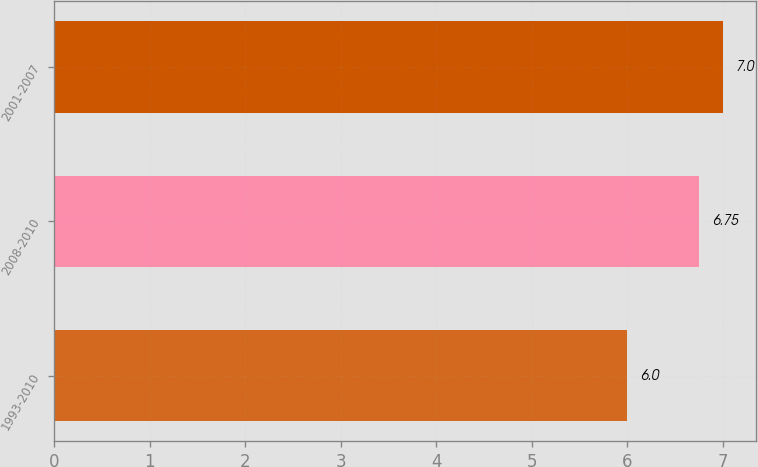Convert chart. <chart><loc_0><loc_0><loc_500><loc_500><bar_chart><fcel>1993-2010<fcel>2008-2010<fcel>2001-2007<nl><fcel>6<fcel>6.75<fcel>7<nl></chart> 